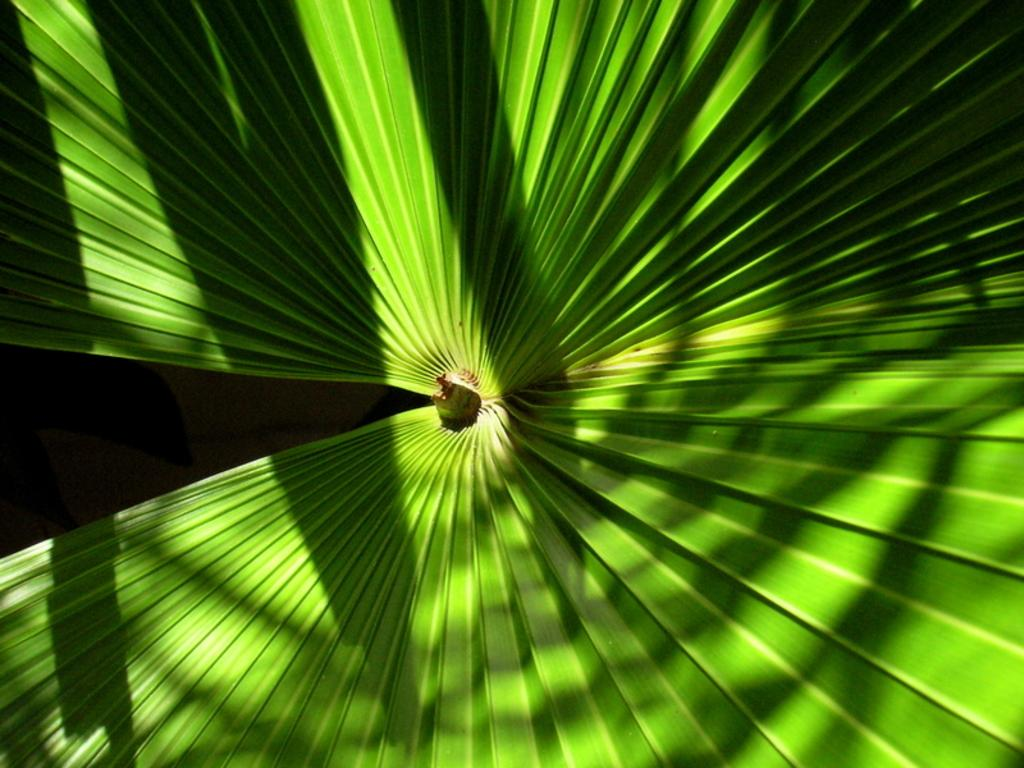What is present in the image related to a plant? There is a leaf in the image, which belongs to a plant. What type of rod is being used to protest in the park in the image? There is no rod, protest, or park present in the image; it only features a leaf belonging to a plant. 